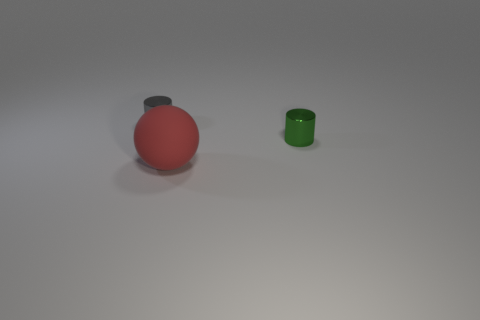Do the red rubber ball and the metal cylinder right of the sphere have the same size?
Give a very brief answer. No. There is a cylinder that is on the right side of the gray metal thing; is it the same size as the red sphere in front of the small green metal cylinder?
Offer a terse response. No. Is the tiny thing left of the green object made of the same material as the large object that is to the left of the green shiny object?
Give a very brief answer. No. What number of shiny objects are the same size as the gray cylinder?
Make the answer very short. 1. Are there fewer gray cylinders than tiny cyan objects?
Ensure brevity in your answer.  No. What is the shape of the large rubber thing in front of the small metal object that is left of the sphere?
Keep it short and to the point. Sphere. What shape is the metallic object that is the same size as the green metallic cylinder?
Provide a succinct answer. Cylinder. Is there another object that has the same shape as the tiny green thing?
Offer a terse response. Yes. What material is the green cylinder?
Your response must be concise. Metal. There is a green shiny cylinder; are there any small gray metal objects on the left side of it?
Offer a terse response. Yes. 